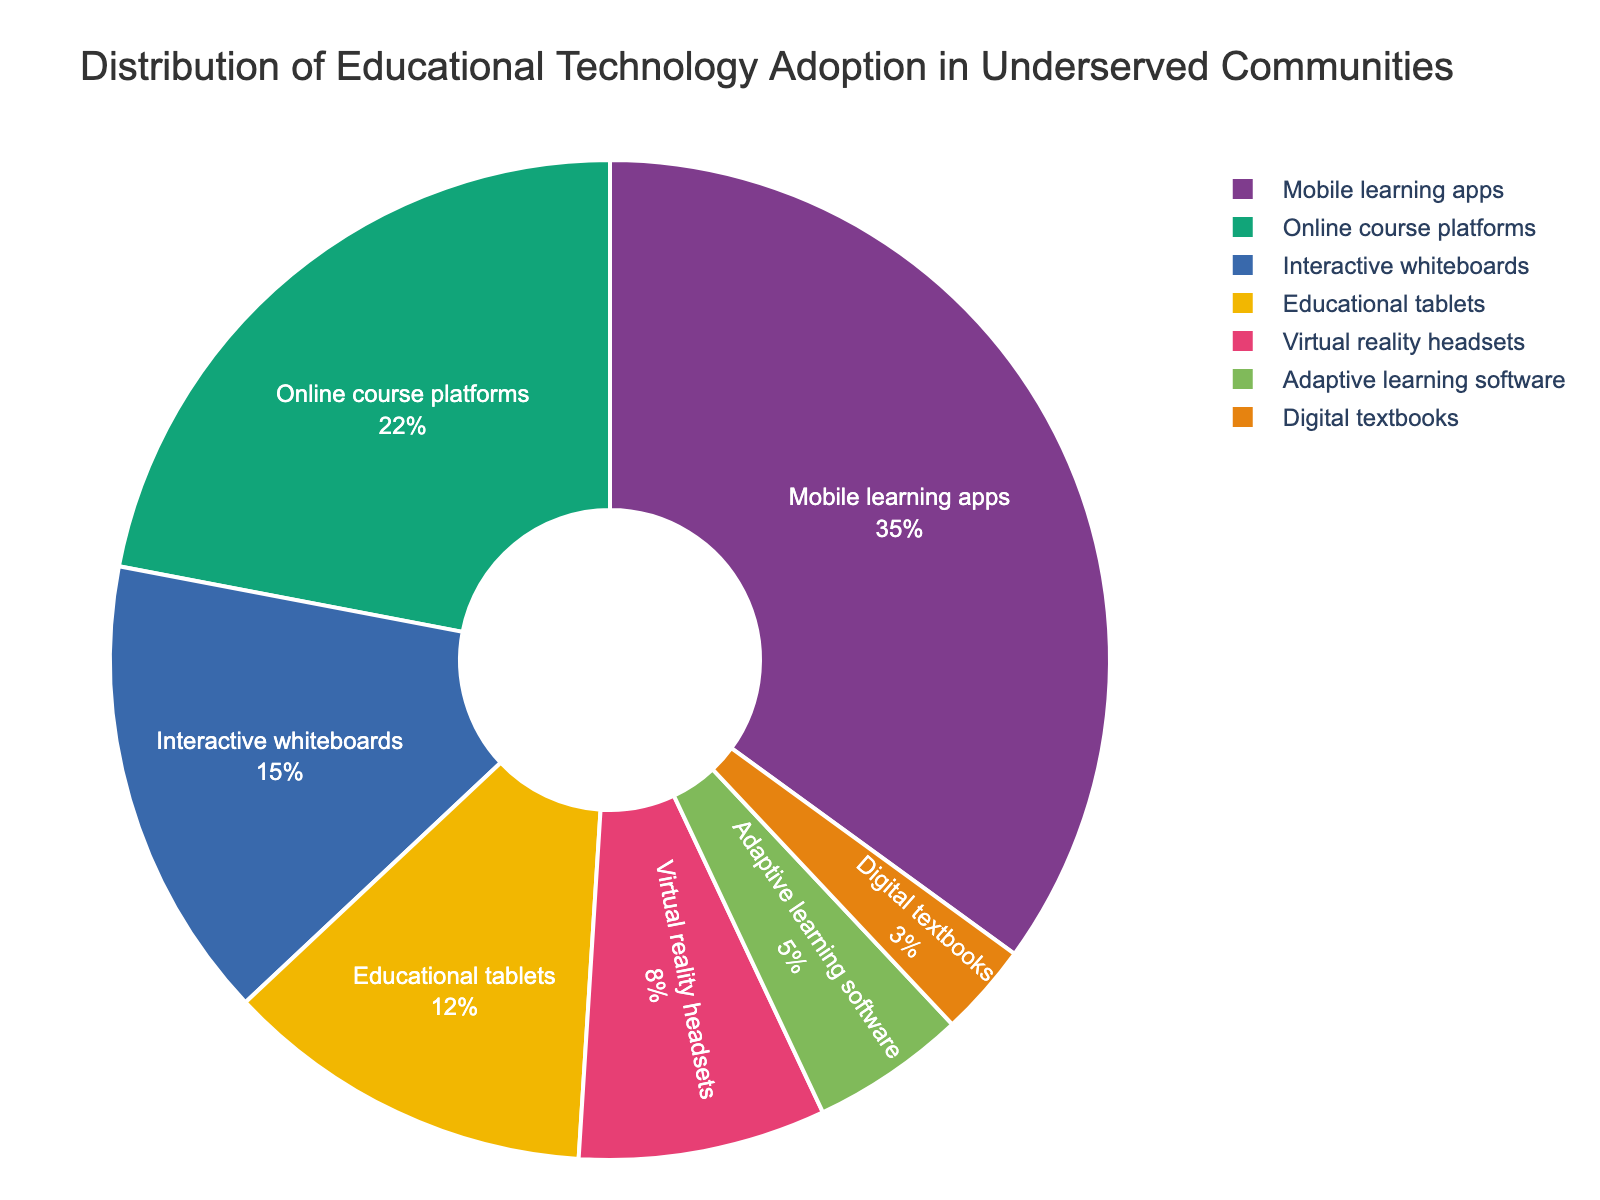what percentage of adoption do Mobile learning apps and Online course platforms have together? The percentages for Mobile learning apps and Online course platforms are 35% and 22% respectively. Adding these together gives 35% + 22% = 57%.
Answer: 57% Which technology has the lowest percentage of adoption? By examining the chart, it can be identified that Digital textbooks have the smallest slice, corresponding to the lowest percentage of 3%.
Answer: Digital textbooks Is the adoption percentage of Adaptive learning software more than twice the adoption of Digital textbooks? Adaptive learning software has an adoption percentage of 5%, and Digital textbooks have 3%. Twice of 3% is 6%, which is more than 5%.
Answer: No What is the color of the slice representing Virtual reality headsets? The slice for Virtual reality headsets has a distinct visual color. By referring to the figure, it is identified that this slice is represented by the color (describe the color seen).
Answer: (Color of the slice) Is the combined adoption percentage of Interactive whiteboards and Educational tablets less than 50%? Interactive whiteboards have 15%, and Educational tablets have 12%. Adding them together gives 15% + 12% = 27%, which is less than 50%.
Answer: Yes Which technology category has the second highest adoption rate? Upon examining the sizes of the slices, Mobile learning apps have the highest adoption rate of 35%, and Online course platforms have the second highest with 22%.
Answer: Online course platforms Are Mobile learning apps and Virtual reality headsets adoption rates closer than Educational tablets and Adaptive learning software? Mobile learning apps and Virtual reality headsets are 35% and 8%, with a difference of 27%. Educational tablets and Adaptive learning software are 12% and 5%, with a difference of 7%. Thus, Educational tablets and Adaptive learning software are closer.
Answer: No What portion of the pie chart is made up by technologies with less than 10% adoption rate? Virtual reality headsets have 8%, Adaptive learning software has 5%, and Digital textbooks have 3%. Adding these together gives 8% + 5% + 3% = 16%.
Answer: 16% How much larger is the percentage of Mobile learning apps compared to Digital textbooks? Mobile learning apps have 35% and Digital textbooks have 3%. The difference is 35% - 3% = 32%.
Answer: 32% 